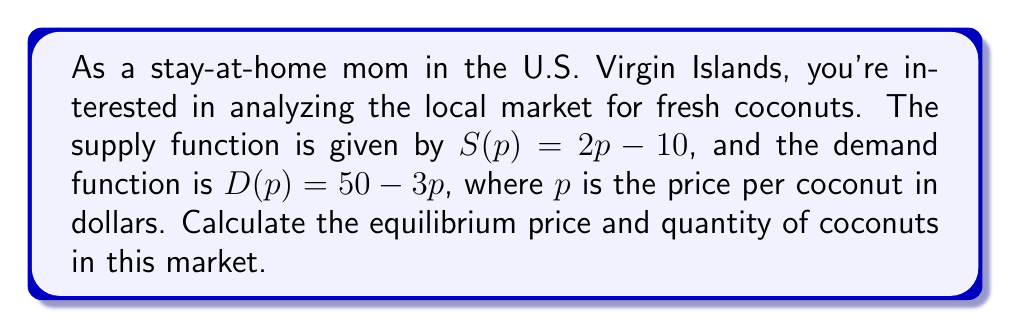Teach me how to tackle this problem. 1. To find the equilibrium, we need to set the supply and demand functions equal to each other:
   $$S(p) = D(p)$$
   $$2p - 10 = 50 - 3p$$

2. Solve the equation for $p$:
   $$2p + 3p = 50 + 10$$
   $$5p = 60$$
   $$p = 12$$

3. The equilibrium price is $12 per coconut.

4. To find the equilibrium quantity, substitute $p = 12$ into either the supply or demand function:
   
   Using the supply function:
   $$S(12) = 2(12) - 10 = 24 - 10 = 14$$
   
   Or using the demand function:
   $$D(12) = 50 - 3(12) = 50 - 36 = 14$$

5. The equilibrium quantity is 14 coconuts.

[asy]
import graph;
size(200,200);
xaxis("Price ($)",0,20,arrow=Arrow);
yaxis("Quantity",0,50,arrow=Arrow);

real s(real x) {return 2x - 10;}
real d(real x) {return 50 - 3x;}

draw(graph(s,5,20),blue);
draw(graph(d,0,16.67),red);

dot((12,14),black);
label("Equilibrium",(12,14),SE);

label("Supply",(18,26),E,blue);
label("Demand",(18,4),E,red);
[/asy]
Answer: Equilibrium price: $12, Equilibrium quantity: 14 